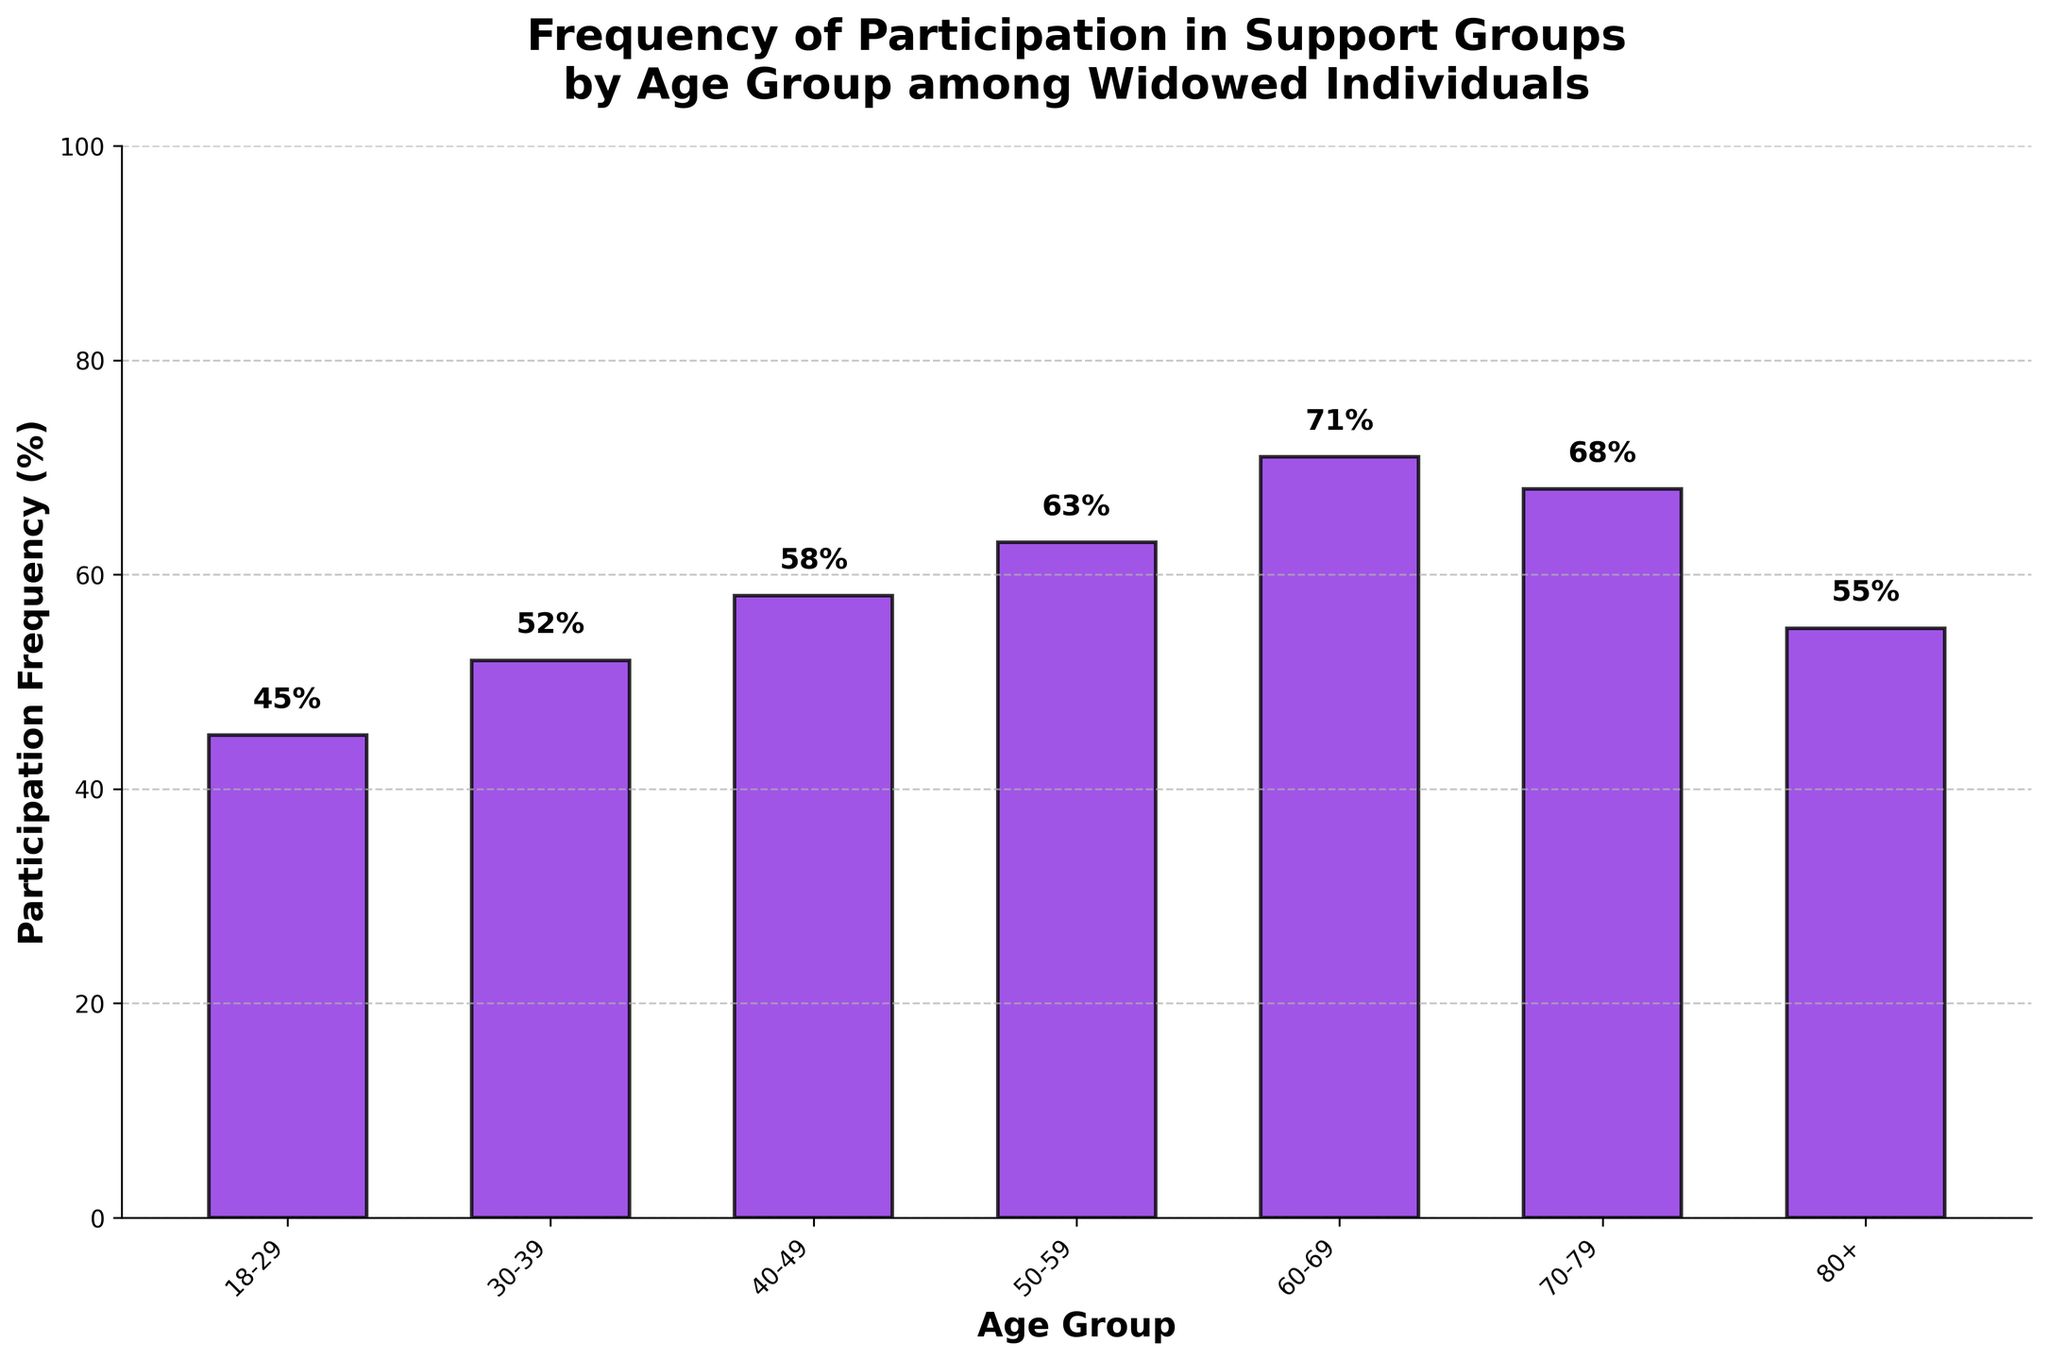What's the participation frequency for the 60-69 age group? The bar for the 60-69 age group indicates the participation frequency.
Answer: 71% Which age group has the highest participation frequency in support groups? The bar for the 60-69 age group is the tallest, indicating the highest participation frequency.
Answer: 60-69 What's the difference in participation frequency between the 40-49 and 50-59 age groups? The participation frequency for the 40-49 age group is 58%, and for the 50-59 age group, it is 63%. The difference is 63% - 58%.
Answer: 5% Which age groups have a participation frequency above 60%? The bars for the 50-59, 60-69, and 70-79 age groups extend above the 60% mark.
Answer: 50-59, 60-69, 70-79 What's the average participation frequency across all age groups? Sum all the participation frequencies and divide by the number of age groups: (45 + 52 + 58 + 63 + 71 + 68 + 55) / 7. The total is 412 and dividing by 7 gives approximately 59%.
Answer: 59% By how much does the participation frequency of the 18-29 age group increase to match that of the 80+ age group? The participation frequency for the 18-29 age group is 45%, and for the 80+ age group, it is 55%. The increase required is 55% - 45%.
Answer: 10% What is the participation frequency for the age group with the lowest participation? The bar for the 18-29 age group is the shortest, indicating the lowest participation frequency.
Answer: 45% How much higher is the participation frequency for the 70-79 age group compared to the 30-39 age group? The participation frequency for the 70-79 age group is 68%, and for the 30-39 age group, it is 52%. The difference is 68% - 52%.
Answer: 16% 